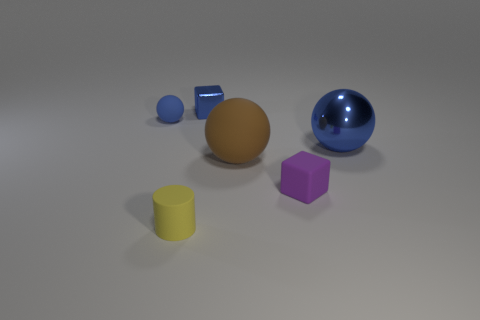Subtract all brown cubes. How many blue spheres are left? 2 Subtract all blue balls. How many balls are left? 1 Add 2 large cyan metal objects. How many objects exist? 8 Subtract all cylinders. How many objects are left? 5 Add 3 large matte objects. How many large matte objects exist? 4 Subtract 1 yellow cylinders. How many objects are left? 5 Subtract all small cubes. Subtract all blocks. How many objects are left? 2 Add 4 purple rubber cubes. How many purple rubber cubes are left? 5 